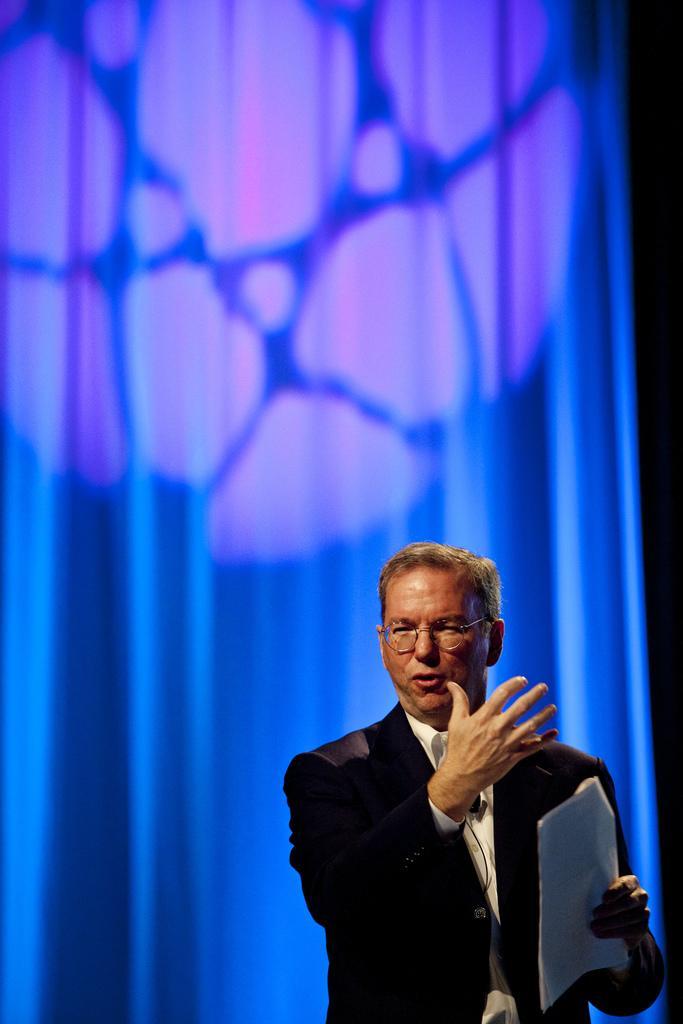Please provide a concise description of this image. In this image there is a person holding a paper. There is a blue color background. 